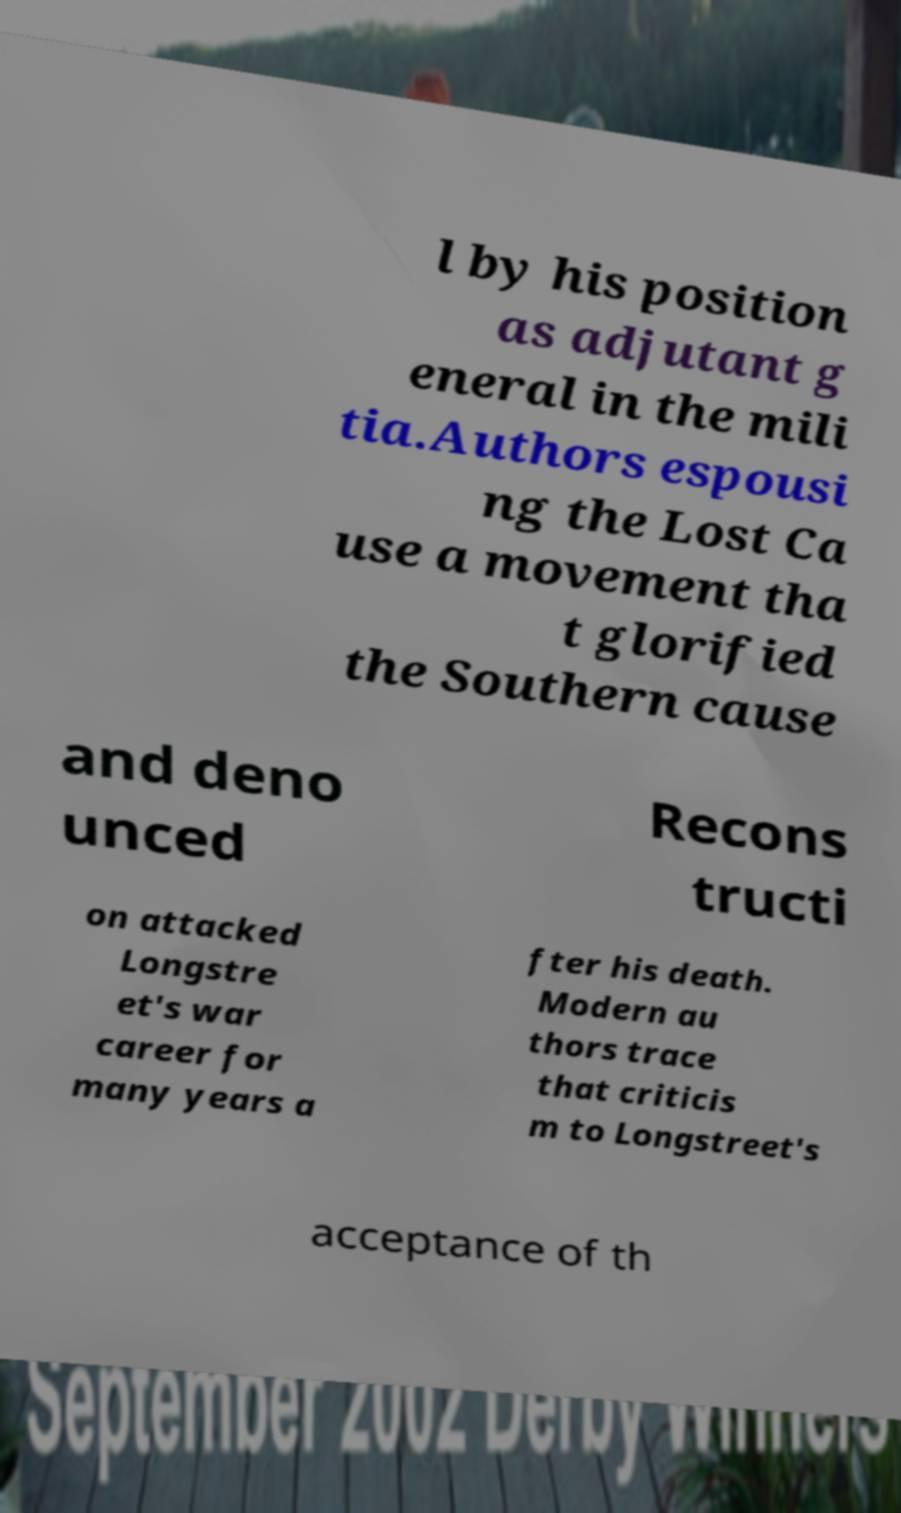What messages or text are displayed in this image? I need them in a readable, typed format. l by his position as adjutant g eneral in the mili tia.Authors espousi ng the Lost Ca use a movement tha t glorified the Southern cause and deno unced Recons tructi on attacked Longstre et's war career for many years a fter his death. Modern au thors trace that criticis m to Longstreet's acceptance of th 